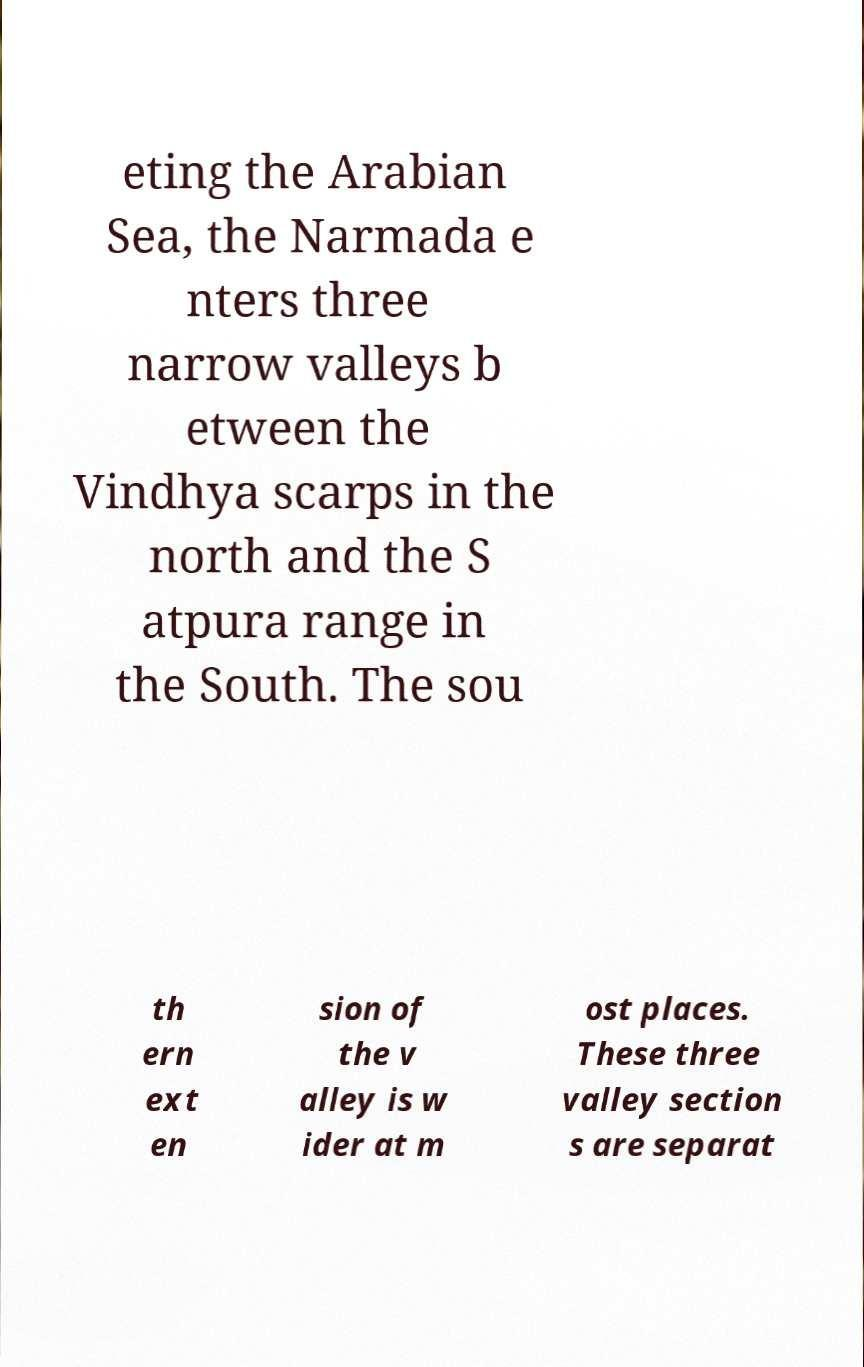Please identify and transcribe the text found in this image. eting the Arabian Sea, the Narmada e nters three narrow valleys b etween the Vindhya scarps in the north and the S atpura range in the South. The sou th ern ext en sion of the v alley is w ider at m ost places. These three valley section s are separat 